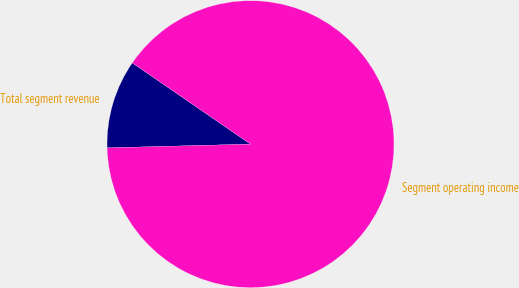<chart> <loc_0><loc_0><loc_500><loc_500><pie_chart><fcel>Total segment revenue<fcel>Segment operating income<nl><fcel>10.0%<fcel>90.0%<nl></chart> 